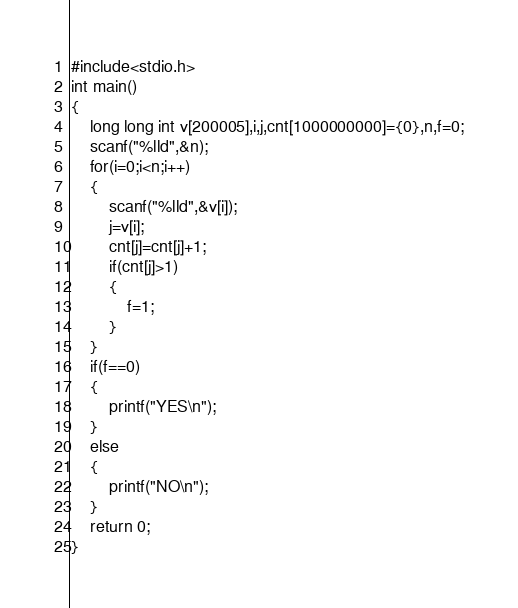<code> <loc_0><loc_0><loc_500><loc_500><_C_>#include<stdio.h>
int main()
{
    long long int v[200005],i,j,cnt[1000000000]={0},n,f=0;
    scanf("%lld",&n);
    for(i=0;i<n;i++)
    {
        scanf("%lld",&v[i]);
        j=v[i];
        cnt[j]=cnt[j]+1;
        if(cnt[j]>1)
        {
            f=1;
        }
    }
    if(f==0)
    {
        printf("YES\n");
    }
    else
    {
        printf("NO\n");
    }
    return 0;
}
</code> 